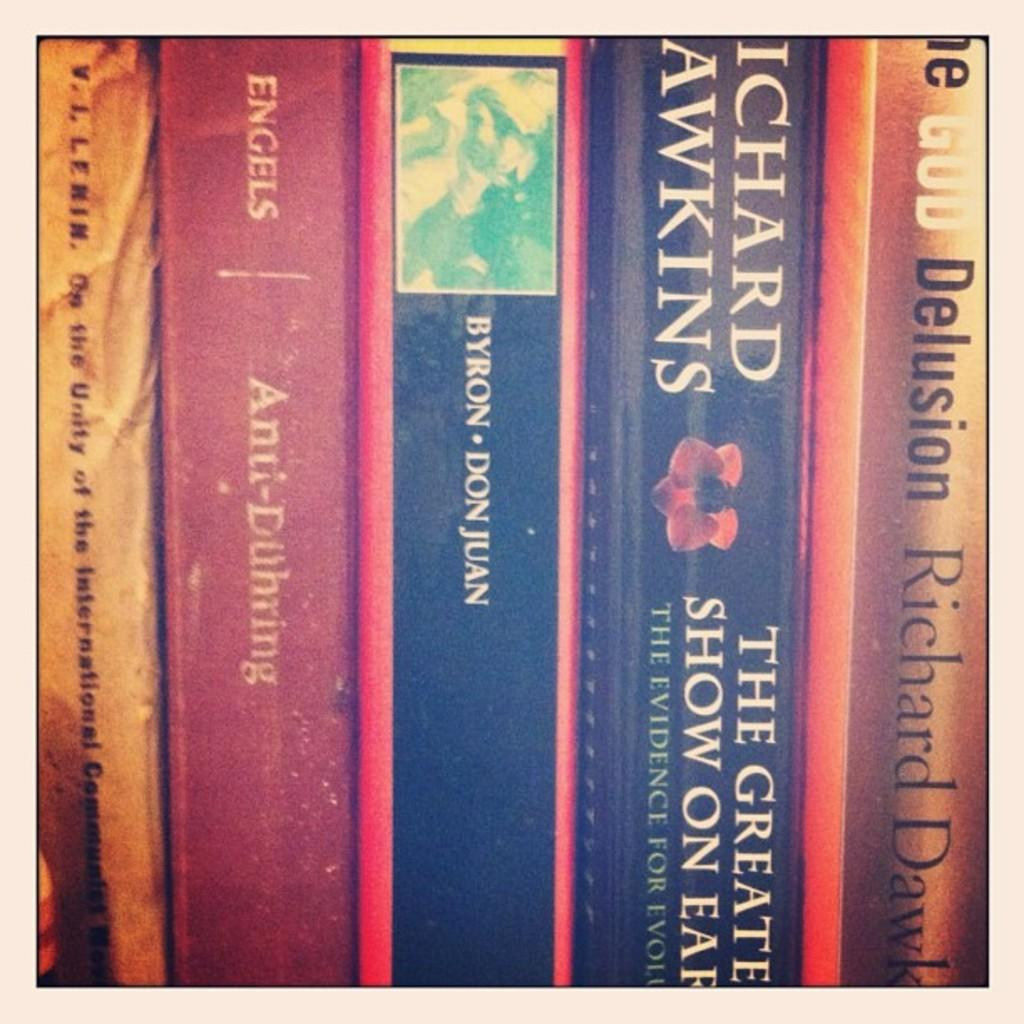Provide a one-sentence caption for the provided image. Several books include Richard Dawkins among their authors. 